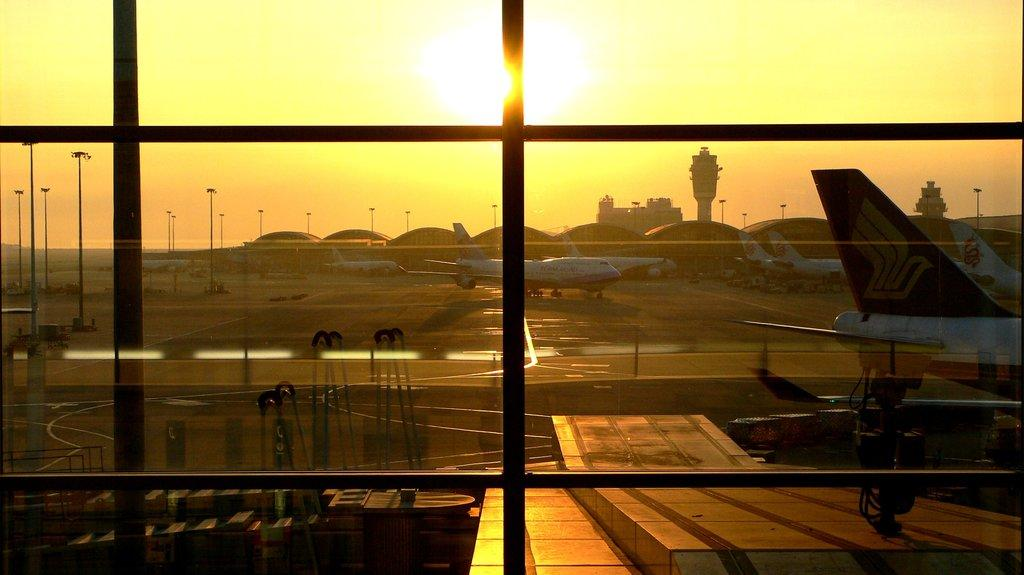What can be seen on the runway road in the image? There are aeroplanes on the runway road in the image. What is the position of the aeroplanes? The aeroplanes are standing. What is visible in the background of the image? There are buildings behind the runway road. What else can be seen on the runway road? There are boxes kept on the road. What type of cover is being used by the band in the image? There is no band present in the image, so it is not possible to determine what type of cover they might be using. 